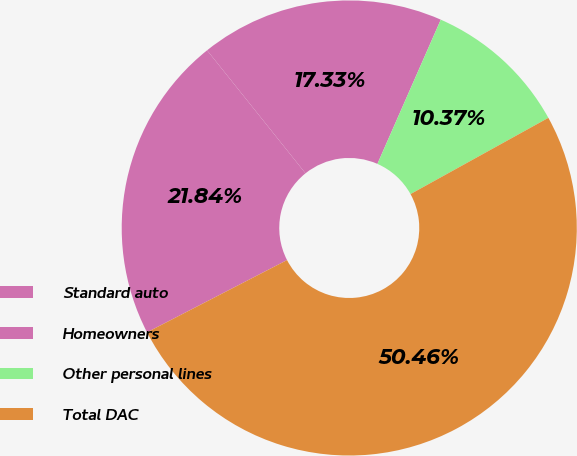<chart> <loc_0><loc_0><loc_500><loc_500><pie_chart><fcel>Standard auto<fcel>Homeowners<fcel>Other personal lines<fcel>Total DAC<nl><fcel>21.84%<fcel>17.33%<fcel>10.37%<fcel>50.46%<nl></chart> 